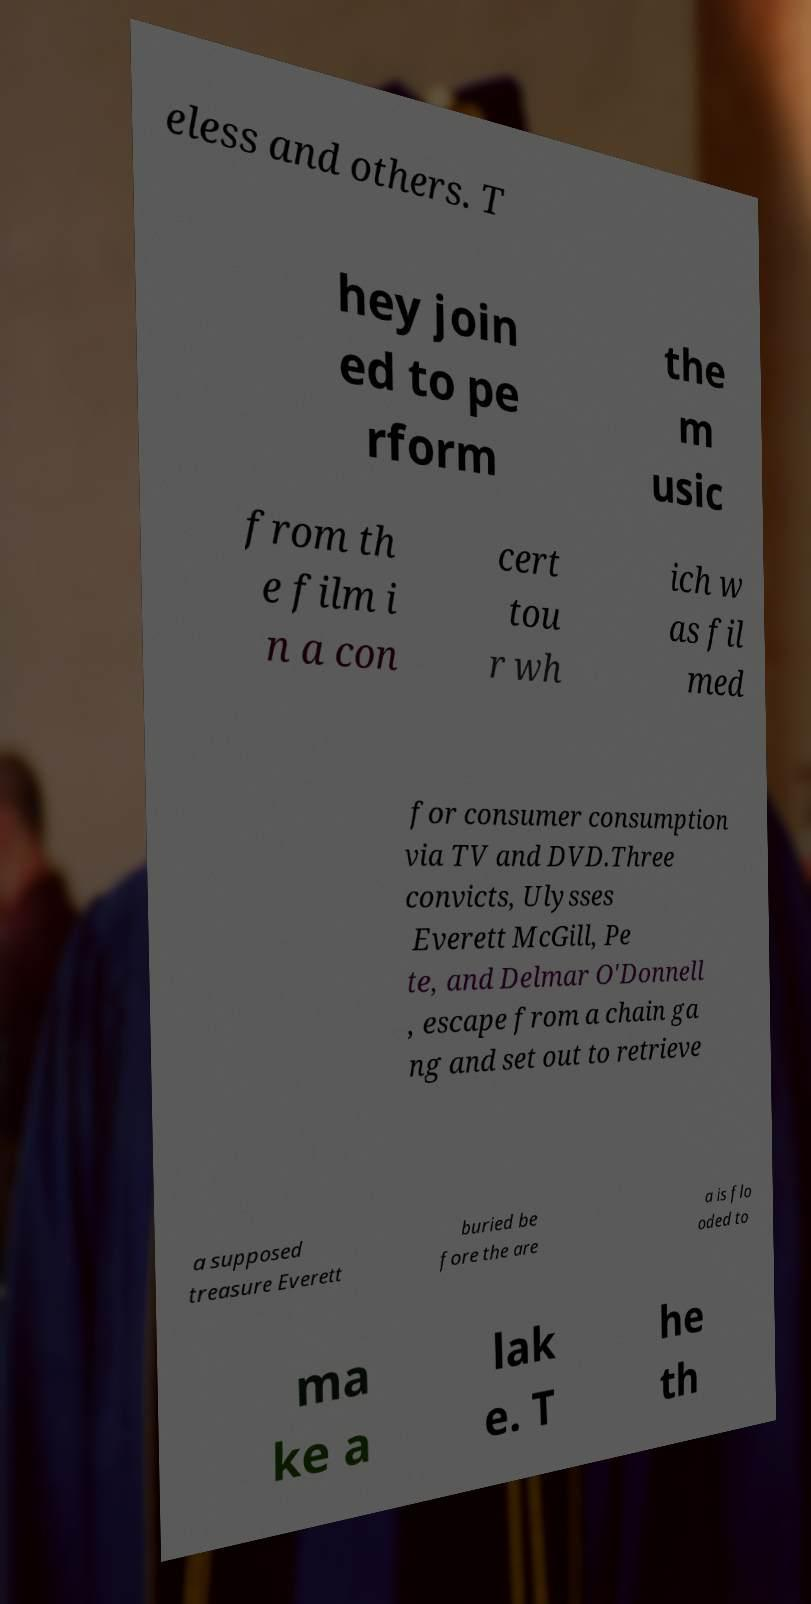Please read and relay the text visible in this image. What does it say? eless and others. T hey join ed to pe rform the m usic from th e film i n a con cert tou r wh ich w as fil med for consumer consumption via TV and DVD.Three convicts, Ulysses Everett McGill, Pe te, and Delmar O'Donnell , escape from a chain ga ng and set out to retrieve a supposed treasure Everett buried be fore the are a is flo oded to ma ke a lak e. T he th 